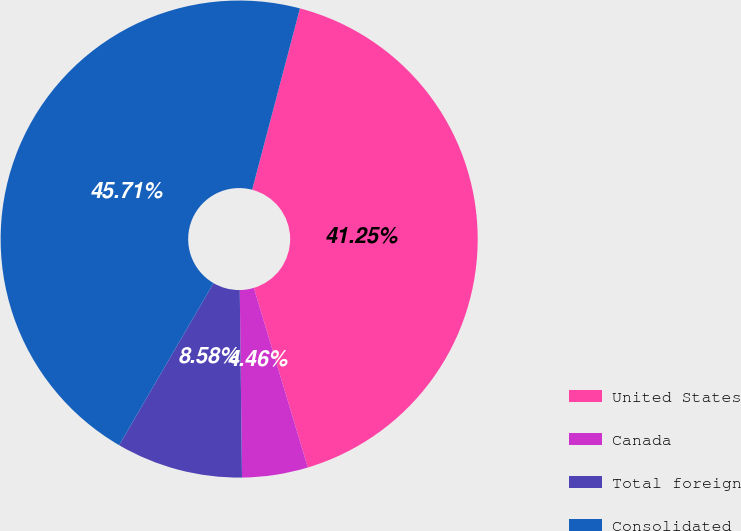Convert chart. <chart><loc_0><loc_0><loc_500><loc_500><pie_chart><fcel>United States<fcel>Canada<fcel>Total foreign<fcel>Consolidated<nl><fcel>41.25%<fcel>4.46%<fcel>8.58%<fcel>45.71%<nl></chart> 